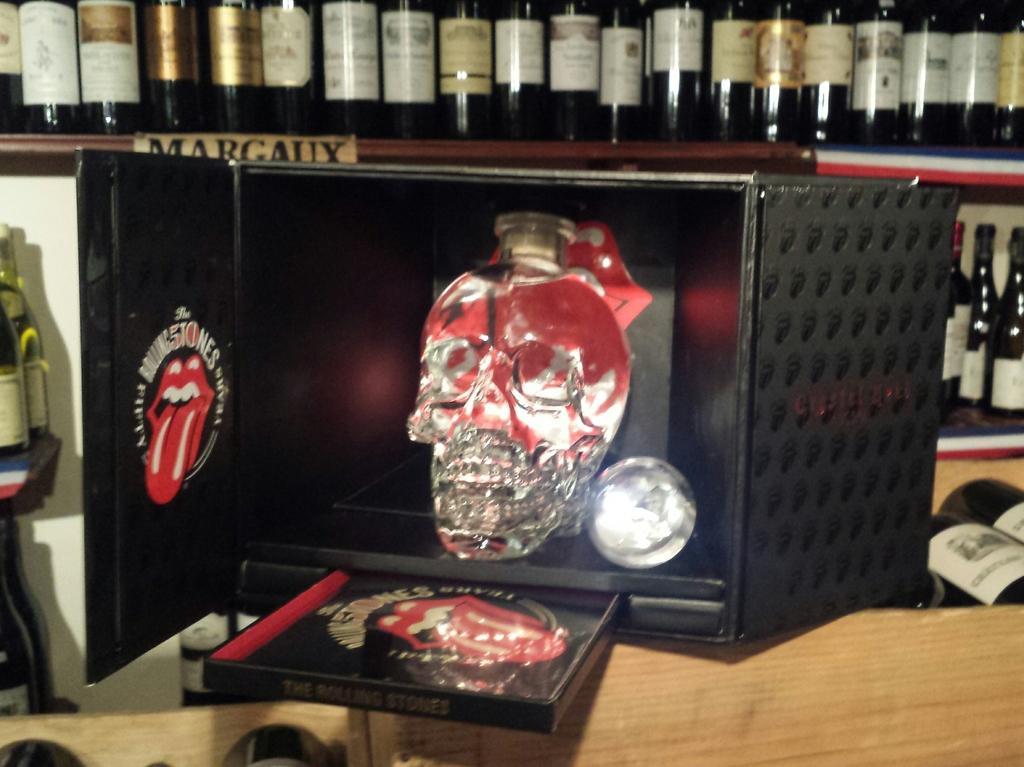Can you describe this image briefly? In this picture we can see a sculpture in the box, beside the box we can find few bottles in the racks. 